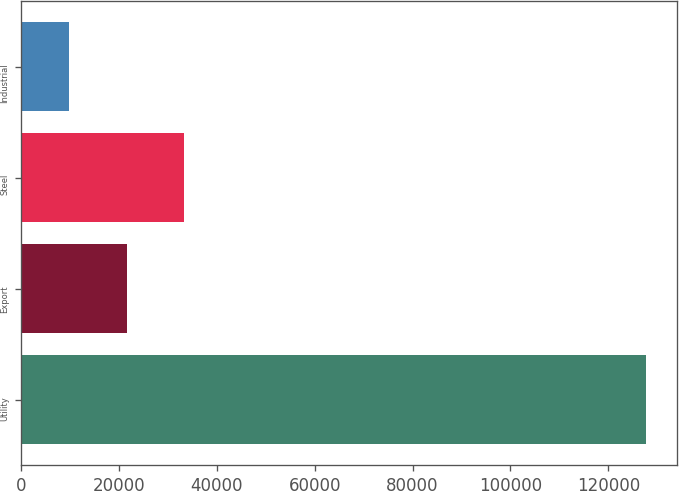<chart> <loc_0><loc_0><loc_500><loc_500><bar_chart><fcel>Utility<fcel>Export<fcel>Steel<fcel>Industrial<nl><fcel>127747<fcel>21534.4<fcel>33335.8<fcel>9733<nl></chart> 